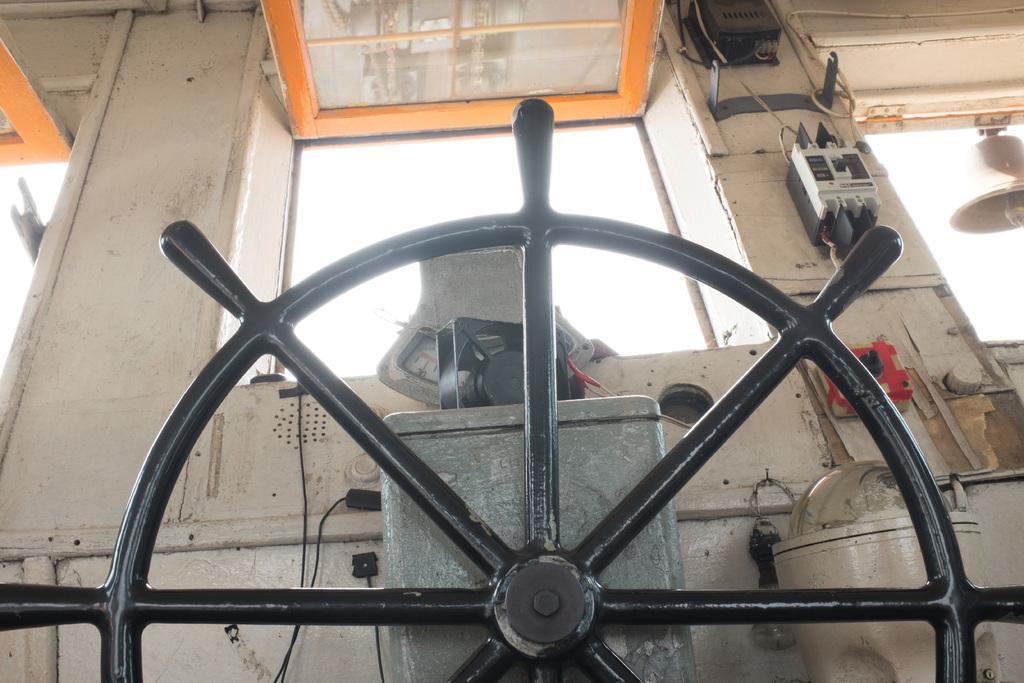In one or two sentences, can you explain what this image depicts? In the center of the image there is a steering. In the background there is a fuse, window, sky and bell. 